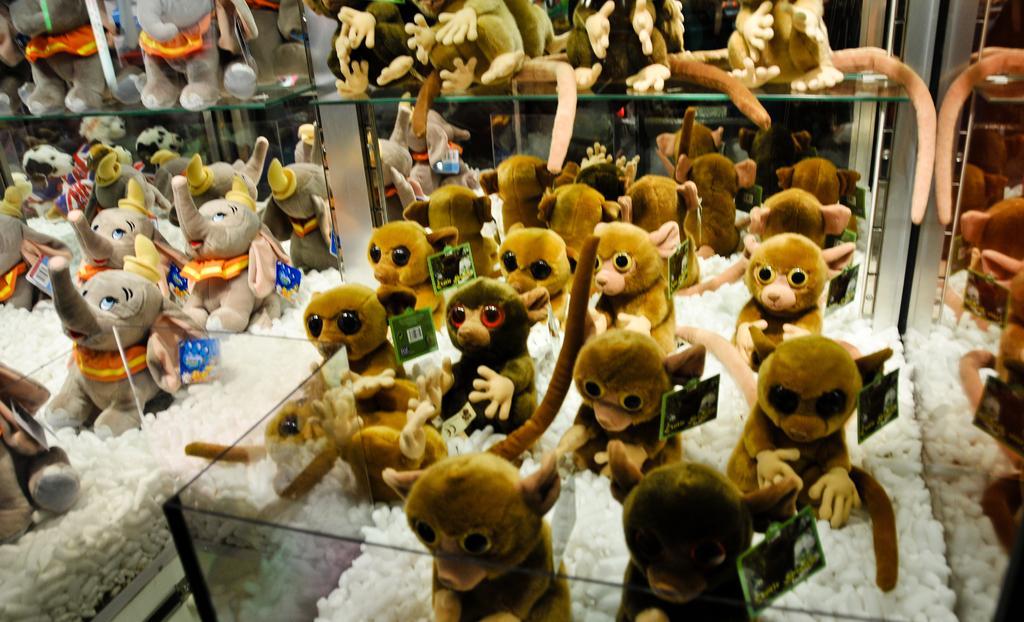Can you describe this image briefly? In this image there are monkey and elephant, toys in a glass box. 